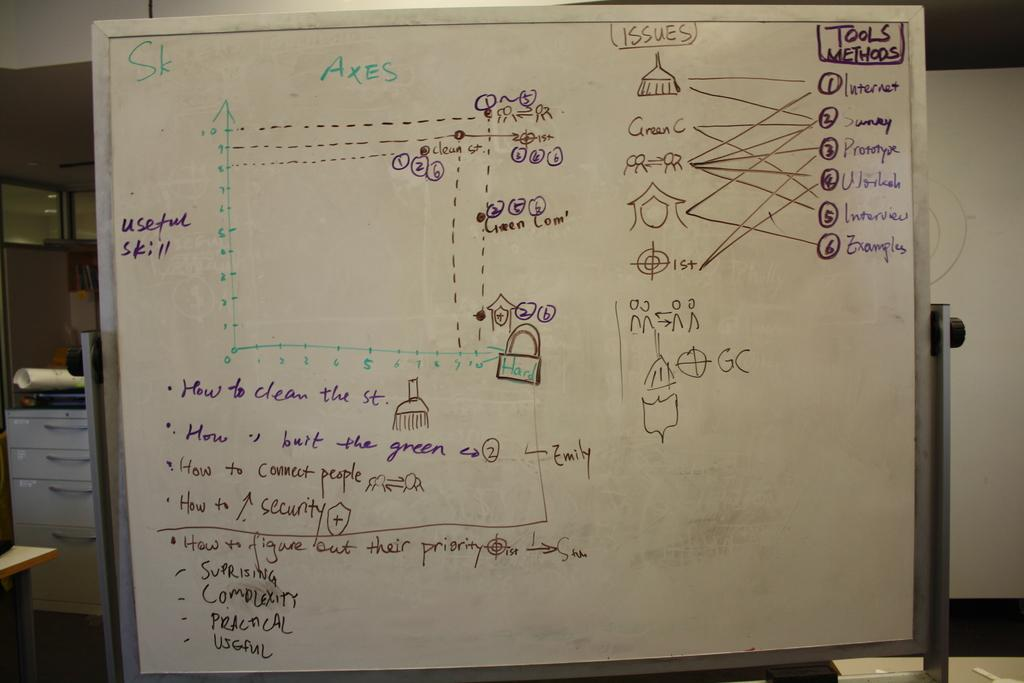<image>
Render a clear and concise summary of the photo. White board showing a diagram about issues and methods 